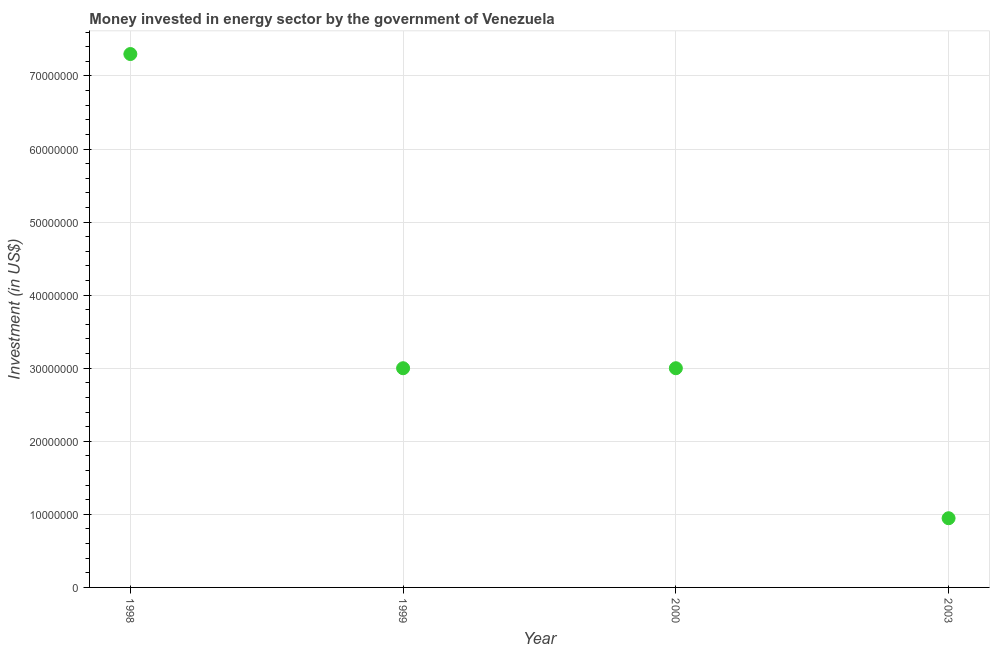What is the investment in energy in 1999?
Your response must be concise. 3.00e+07. Across all years, what is the maximum investment in energy?
Offer a terse response. 7.30e+07. Across all years, what is the minimum investment in energy?
Provide a short and direct response. 9.47e+06. In which year was the investment in energy minimum?
Your response must be concise. 2003. What is the sum of the investment in energy?
Your answer should be very brief. 1.42e+08. What is the difference between the investment in energy in 1998 and 1999?
Your answer should be very brief. 4.30e+07. What is the average investment in energy per year?
Your answer should be very brief. 3.56e+07. What is the median investment in energy?
Give a very brief answer. 3.00e+07. What is the ratio of the investment in energy in 1998 to that in 2003?
Provide a short and direct response. 7.71. Is the investment in energy in 1998 less than that in 1999?
Your response must be concise. No. Is the difference between the investment in energy in 1998 and 2000 greater than the difference between any two years?
Offer a terse response. No. What is the difference between the highest and the second highest investment in energy?
Ensure brevity in your answer.  4.30e+07. What is the difference between the highest and the lowest investment in energy?
Offer a very short reply. 6.35e+07. In how many years, is the investment in energy greater than the average investment in energy taken over all years?
Give a very brief answer. 1. What is the difference between two consecutive major ticks on the Y-axis?
Your answer should be very brief. 1.00e+07. Are the values on the major ticks of Y-axis written in scientific E-notation?
Offer a very short reply. No. Does the graph contain any zero values?
Keep it short and to the point. No. What is the title of the graph?
Keep it short and to the point. Money invested in energy sector by the government of Venezuela. What is the label or title of the Y-axis?
Provide a succinct answer. Investment (in US$). What is the Investment (in US$) in 1998?
Provide a short and direct response. 7.30e+07. What is the Investment (in US$) in 1999?
Ensure brevity in your answer.  3.00e+07. What is the Investment (in US$) in 2000?
Offer a terse response. 3.00e+07. What is the Investment (in US$) in 2003?
Make the answer very short. 9.47e+06. What is the difference between the Investment (in US$) in 1998 and 1999?
Offer a very short reply. 4.30e+07. What is the difference between the Investment (in US$) in 1998 and 2000?
Your response must be concise. 4.30e+07. What is the difference between the Investment (in US$) in 1998 and 2003?
Provide a short and direct response. 6.35e+07. What is the difference between the Investment (in US$) in 1999 and 2003?
Keep it short and to the point. 2.05e+07. What is the difference between the Investment (in US$) in 2000 and 2003?
Make the answer very short. 2.05e+07. What is the ratio of the Investment (in US$) in 1998 to that in 1999?
Keep it short and to the point. 2.43. What is the ratio of the Investment (in US$) in 1998 to that in 2000?
Your response must be concise. 2.43. What is the ratio of the Investment (in US$) in 1998 to that in 2003?
Your response must be concise. 7.71. What is the ratio of the Investment (in US$) in 1999 to that in 2003?
Ensure brevity in your answer.  3.17. What is the ratio of the Investment (in US$) in 2000 to that in 2003?
Your answer should be compact. 3.17. 